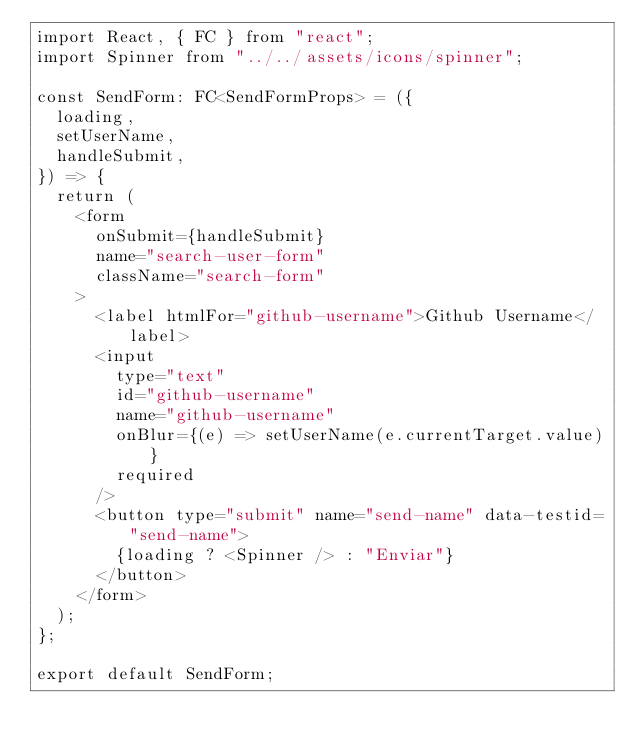Convert code to text. <code><loc_0><loc_0><loc_500><loc_500><_TypeScript_>import React, { FC } from "react";
import Spinner from "../../assets/icons/spinner";

const SendForm: FC<SendFormProps> = ({
  loading,
  setUserName,
  handleSubmit,
}) => {
  return (
    <form
      onSubmit={handleSubmit}
      name="search-user-form"
      className="search-form"
    >
      <label htmlFor="github-username">Github Username</label>
      <input
        type="text"
        id="github-username"
        name="github-username"
        onBlur={(e) => setUserName(e.currentTarget.value)}
        required
      />
      <button type="submit" name="send-name" data-testid="send-name">
        {loading ? <Spinner /> : "Enviar"}
      </button>
    </form>
  );
};

export default SendForm;
</code> 